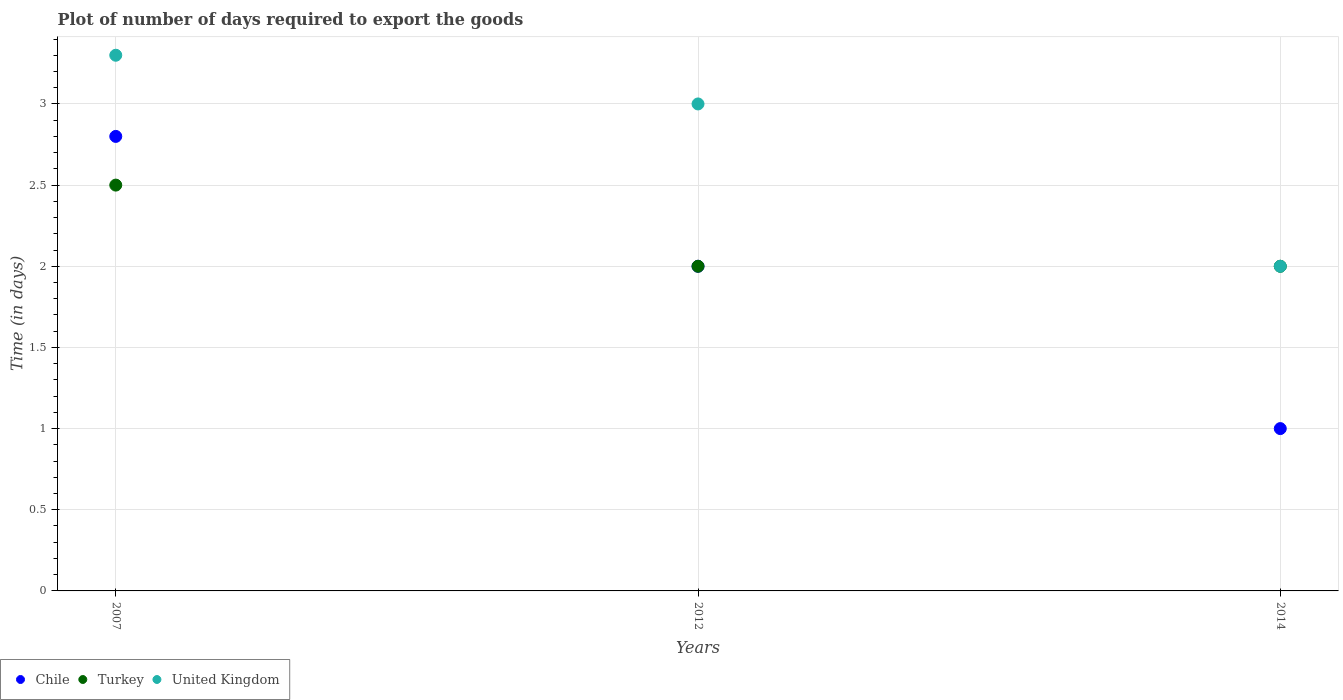How many different coloured dotlines are there?
Your answer should be compact. 3. Is the number of dotlines equal to the number of legend labels?
Your answer should be compact. Yes. What is the time required to export goods in United Kingdom in 2014?
Your answer should be compact. 2. Across all years, what is the maximum time required to export goods in Chile?
Your answer should be compact. 2.8. Across all years, what is the minimum time required to export goods in Turkey?
Offer a very short reply. 2. In which year was the time required to export goods in United Kingdom maximum?
Make the answer very short. 2007. In which year was the time required to export goods in Chile minimum?
Provide a succinct answer. 2014. What is the difference between the time required to export goods in Chile in 2007 and that in 2012?
Make the answer very short. 0.8. What is the difference between the time required to export goods in United Kingdom in 2007 and the time required to export goods in Turkey in 2012?
Offer a terse response. 1.3. What is the average time required to export goods in United Kingdom per year?
Offer a terse response. 2.77. In how many years, is the time required to export goods in United Kingdom greater than 2.5 days?
Ensure brevity in your answer.  2. What is the ratio of the time required to export goods in United Kingdom in 2007 to that in 2012?
Ensure brevity in your answer.  1.1. Is the time required to export goods in United Kingdom in 2012 less than that in 2014?
Provide a short and direct response. No. What is the difference between the highest and the second highest time required to export goods in Chile?
Give a very brief answer. 0.8. What is the difference between the highest and the lowest time required to export goods in United Kingdom?
Offer a very short reply. 1.3. Is the sum of the time required to export goods in Turkey in 2012 and 2014 greater than the maximum time required to export goods in Chile across all years?
Your answer should be compact. Yes. Is it the case that in every year, the sum of the time required to export goods in Turkey and time required to export goods in Chile  is greater than the time required to export goods in United Kingdom?
Offer a terse response. Yes. Is the time required to export goods in Chile strictly less than the time required to export goods in Turkey over the years?
Your answer should be compact. No. How many years are there in the graph?
Ensure brevity in your answer.  3. What is the difference between two consecutive major ticks on the Y-axis?
Offer a very short reply. 0.5. Are the values on the major ticks of Y-axis written in scientific E-notation?
Make the answer very short. No. Does the graph contain any zero values?
Make the answer very short. No. What is the title of the graph?
Provide a short and direct response. Plot of number of days required to export the goods. What is the label or title of the Y-axis?
Give a very brief answer. Time (in days). What is the Time (in days) of Turkey in 2007?
Give a very brief answer. 2.5. What is the Time (in days) in United Kingdom in 2007?
Offer a terse response. 3.3. What is the Time (in days) of United Kingdom in 2012?
Provide a succinct answer. 3. What is the Time (in days) of Chile in 2014?
Provide a succinct answer. 1. What is the Time (in days) of Turkey in 2014?
Offer a terse response. 2. What is the Time (in days) of United Kingdom in 2014?
Offer a terse response. 2. Across all years, what is the minimum Time (in days) of Chile?
Your answer should be very brief. 1. Across all years, what is the minimum Time (in days) of Turkey?
Provide a short and direct response. 2. Across all years, what is the minimum Time (in days) in United Kingdom?
Offer a terse response. 2. What is the total Time (in days) in Chile in the graph?
Give a very brief answer. 5.8. What is the total Time (in days) of United Kingdom in the graph?
Your answer should be very brief. 8.3. What is the difference between the Time (in days) of Chile in 2007 and that in 2012?
Make the answer very short. 0.8. What is the difference between the Time (in days) of Turkey in 2007 and that in 2012?
Offer a very short reply. 0.5. What is the difference between the Time (in days) of Turkey in 2007 and that in 2014?
Your answer should be compact. 0.5. What is the difference between the Time (in days) of Chile in 2012 and that in 2014?
Keep it short and to the point. 1. What is the difference between the Time (in days) in Turkey in 2012 and that in 2014?
Give a very brief answer. 0. What is the difference between the Time (in days) of United Kingdom in 2012 and that in 2014?
Keep it short and to the point. 1. What is the difference between the Time (in days) of Chile in 2007 and the Time (in days) of Turkey in 2012?
Provide a short and direct response. 0.8. What is the difference between the Time (in days) of Turkey in 2007 and the Time (in days) of United Kingdom in 2012?
Your answer should be compact. -0.5. What is the difference between the Time (in days) of Chile in 2007 and the Time (in days) of United Kingdom in 2014?
Your response must be concise. 0.8. What is the difference between the Time (in days) of Chile in 2012 and the Time (in days) of Turkey in 2014?
Your answer should be very brief. 0. What is the average Time (in days) of Chile per year?
Offer a very short reply. 1.93. What is the average Time (in days) of Turkey per year?
Offer a very short reply. 2.17. What is the average Time (in days) of United Kingdom per year?
Your answer should be very brief. 2.77. In the year 2012, what is the difference between the Time (in days) of Chile and Time (in days) of Turkey?
Your answer should be compact. 0. In the year 2014, what is the difference between the Time (in days) of Chile and Time (in days) of United Kingdom?
Give a very brief answer. -1. What is the ratio of the Time (in days) in Chile in 2007 to that in 2012?
Keep it short and to the point. 1.4. What is the ratio of the Time (in days) of Turkey in 2007 to that in 2012?
Offer a very short reply. 1.25. What is the ratio of the Time (in days) of United Kingdom in 2007 to that in 2012?
Make the answer very short. 1.1. What is the ratio of the Time (in days) in Turkey in 2007 to that in 2014?
Give a very brief answer. 1.25. What is the ratio of the Time (in days) of United Kingdom in 2007 to that in 2014?
Give a very brief answer. 1.65. What is the difference between the highest and the second highest Time (in days) in Chile?
Give a very brief answer. 0.8. 